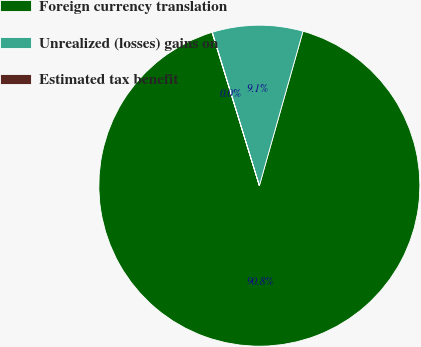<chart> <loc_0><loc_0><loc_500><loc_500><pie_chart><fcel>Foreign currency translation<fcel>Unrealized (losses) gains on<fcel>Estimated tax benefit<nl><fcel>90.85%<fcel>9.12%<fcel>0.03%<nl></chart> 